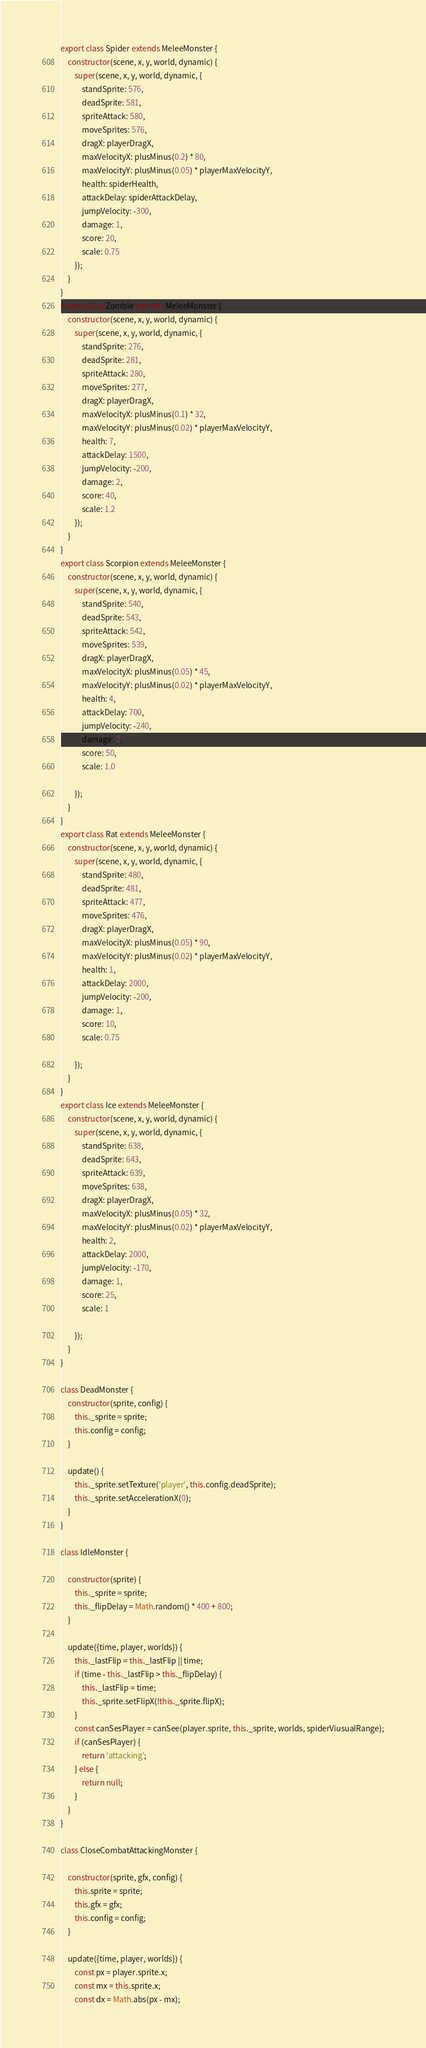<code> <loc_0><loc_0><loc_500><loc_500><_JavaScript_>export class Spider extends MeleeMonster {
    constructor(scene, x, y, world, dynamic) {
        super(scene, x, y, world, dynamic, {
            standSprite: 576,
            deadSprite: 581,
            spriteAttack: 580,
            moveSprites: 576,
            dragX: playerDragX,
            maxVelocityX: plusMinus(0.2) * 80,
            maxVelocityY: plusMinus(0.05) * playerMaxVelocityY,
            health: spiderHealth,
            attackDelay: spiderAttackDelay,
            jumpVelocity: -300,
            damage: 1,
            score: 20,
            scale: 0.75
        });
    }
}
export class Zombie extends MeleeMonster {
    constructor(scene, x, y, world, dynamic) {
        super(scene, x, y, world, dynamic, {
            standSprite: 276,
            deadSprite: 281,
            spriteAttack: 280,
            moveSprites: 277,
            dragX: playerDragX,
            maxVelocityX: plusMinus(0.1) * 32,
            maxVelocityY: plusMinus(0.02) * playerMaxVelocityY,
            health: 7,
            attackDelay: 1500,
            jumpVelocity: -200,
            damage: 2,
            score: 40,
            scale: 1.2
        });
    }
}
export class Scorpion extends MeleeMonster {
    constructor(scene, x, y, world, dynamic) {
        super(scene, x, y, world, dynamic, {
            standSprite: 540,
            deadSprite: 543,
            spriteAttack: 542,
            moveSprites: 539,
            dragX: playerDragX,
            maxVelocityX: plusMinus(0.05) * 45,
            maxVelocityY: plusMinus(0.02) * playerMaxVelocityY,
            health: 4,
            attackDelay: 700,
            jumpVelocity: -240,
            damage: 2,
            score: 50,
            scale: 1.0

        });
    }
}
export class Rat extends MeleeMonster {
    constructor(scene, x, y, world, dynamic) {
        super(scene, x, y, world, dynamic, {
            standSprite: 480,
            deadSprite: 481,
            spriteAttack: 477,
            moveSprites: 476,
            dragX: playerDragX,
            maxVelocityX: plusMinus(0.05) * 90,
            maxVelocityY: plusMinus(0.02) * playerMaxVelocityY,
            health: 1,
            attackDelay: 2000,
            jumpVelocity: -200,
            damage: 1,
            score: 10,
            scale: 0.75

        });
    }
}
export class Ice extends MeleeMonster {
    constructor(scene, x, y, world, dynamic) {
        super(scene, x, y, world, dynamic, {
            standSprite: 638,
            deadSprite: 643,
            spriteAttack: 639,
            moveSprites: 638,
            dragX: playerDragX,
            maxVelocityX: plusMinus(0.05) * 32,
            maxVelocityY: plusMinus(0.02) * playerMaxVelocityY,
            health: 2,
            attackDelay: 2000,
            jumpVelocity: -170,
            damage: 1,
            score: 25,
            scale: 1

        });
    }
}

class DeadMonster {
    constructor(sprite, config) {
        this._sprite = sprite;
        this.config = config;
    }

    update() {
        this._sprite.setTexture('player', this.config.deadSprite);
        this._sprite.setAccelerationX(0);
    }
}

class IdleMonster {

    constructor(sprite) {
        this._sprite = sprite;
        this._flipDelay = Math.random() * 400 + 800;
    }

    update({time, player, worlds}) {
        this._lastFlip = this._lastFlip || time;
        if (time - this._lastFlip > this._flipDelay) {
            this._lastFlip = time;
            this._sprite.setFlipX(!this._sprite.flipX);
        }
        const canSesPlayer = canSee(player.sprite, this._sprite, worlds, spiderViusualRange);
        if (canSesPlayer) {
            return 'attacking';
        } else {
            return null;
        }
    }
}

class CloseCombatAttackingMonster {

    constructor(sprite, gfx, config) {
        this.sprite = sprite;
        this.gfx = gfx;
        this.config = config;
    }

    update({time, player, worlds}) {
        const px = player.sprite.x;
        const mx = this.sprite.x;
        const dx = Math.abs(px - mx);</code> 